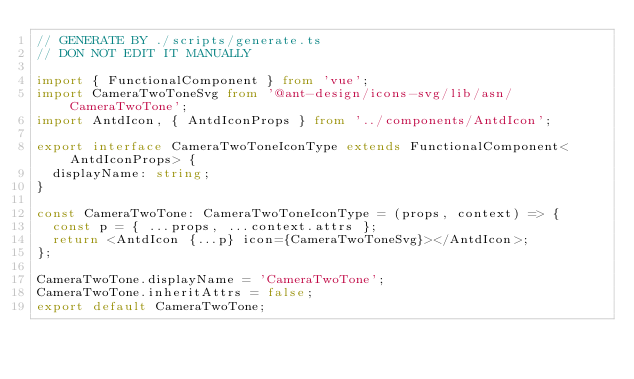Convert code to text. <code><loc_0><loc_0><loc_500><loc_500><_TypeScript_>// GENERATE BY ./scripts/generate.ts
// DON NOT EDIT IT MANUALLY

import { FunctionalComponent } from 'vue';
import CameraTwoToneSvg from '@ant-design/icons-svg/lib/asn/CameraTwoTone';
import AntdIcon, { AntdIconProps } from '../components/AntdIcon';

export interface CameraTwoToneIconType extends FunctionalComponent<AntdIconProps> {
  displayName: string;
}

const CameraTwoTone: CameraTwoToneIconType = (props, context) => {
  const p = { ...props, ...context.attrs };
  return <AntdIcon {...p} icon={CameraTwoToneSvg}></AntdIcon>;
};

CameraTwoTone.displayName = 'CameraTwoTone';
CameraTwoTone.inheritAttrs = false;
export default CameraTwoTone;</code> 